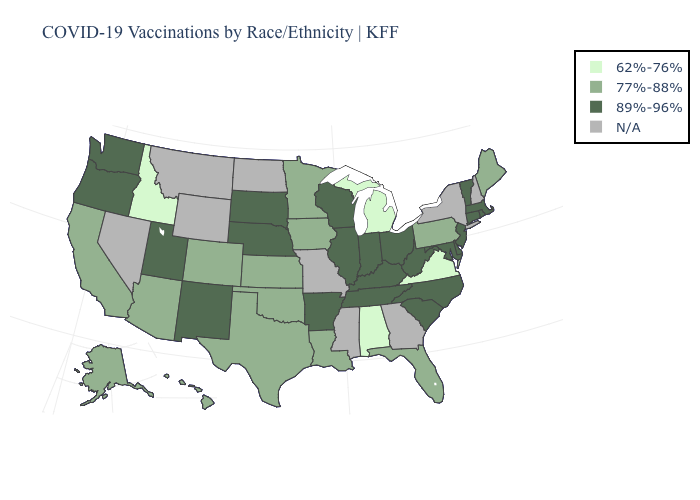Name the states that have a value in the range 77%-88%?
Write a very short answer. Alaska, Arizona, California, Colorado, Florida, Hawaii, Iowa, Kansas, Louisiana, Maine, Minnesota, Oklahoma, Pennsylvania, Texas. Name the states that have a value in the range 62%-76%?
Write a very short answer. Alabama, Idaho, Michigan, Virginia. Among the states that border Nevada , does California have the highest value?
Concise answer only. No. Name the states that have a value in the range N/A?
Be succinct. Georgia, Mississippi, Missouri, Montana, Nevada, New Hampshire, New York, North Dakota, Wyoming. What is the highest value in states that border North Carolina?
Be succinct. 89%-96%. Does Pennsylvania have the lowest value in the Northeast?
Concise answer only. Yes. What is the value of Connecticut?
Quick response, please. 89%-96%. Name the states that have a value in the range 77%-88%?
Concise answer only. Alaska, Arizona, California, Colorado, Florida, Hawaii, Iowa, Kansas, Louisiana, Maine, Minnesota, Oklahoma, Pennsylvania, Texas. Does Louisiana have the highest value in the South?
Quick response, please. No. What is the highest value in the USA?
Give a very brief answer. 89%-96%. What is the value of Colorado?
Keep it brief. 77%-88%. What is the value of Delaware?
Keep it brief. 89%-96%. 